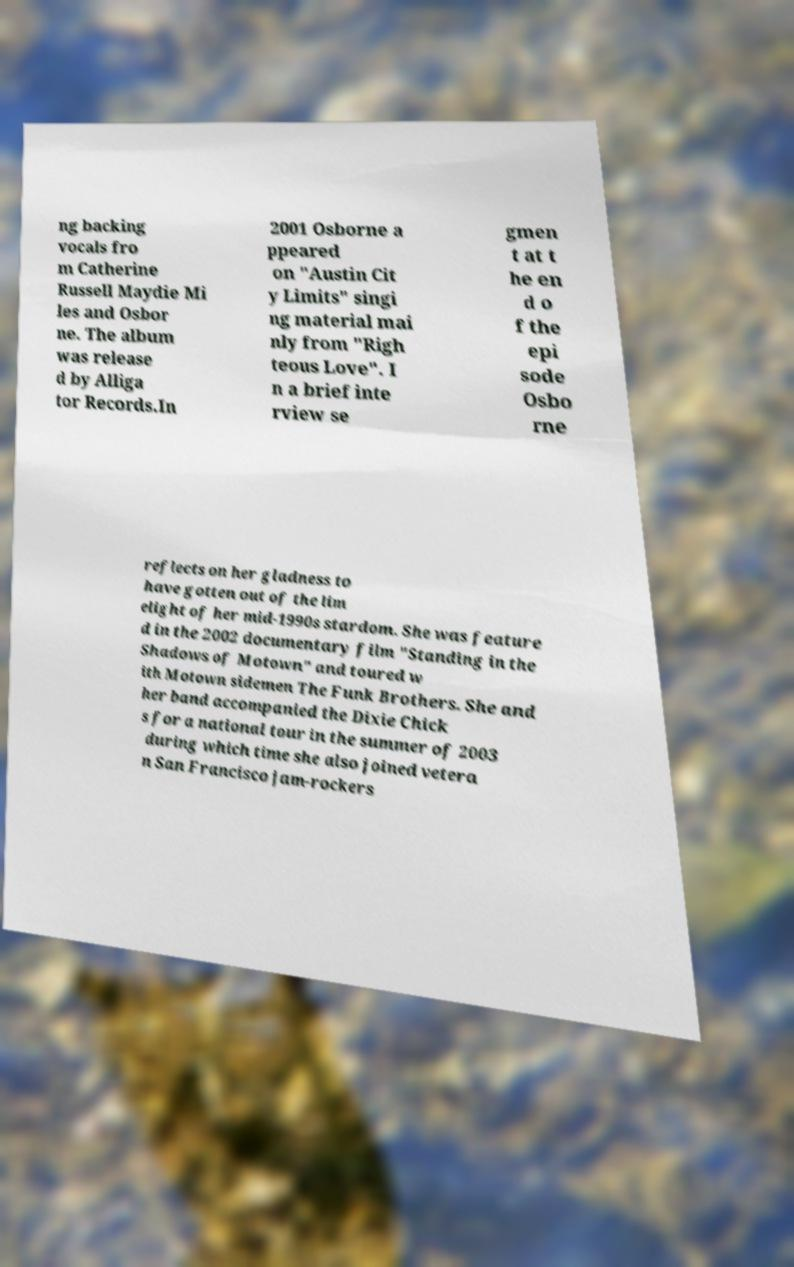Can you read and provide the text displayed in the image?This photo seems to have some interesting text. Can you extract and type it out for me? ng backing vocals fro m Catherine Russell Maydie Mi les and Osbor ne. The album was release d by Alliga tor Records.In 2001 Osborne a ppeared on "Austin Cit y Limits" singi ng material mai nly from "Righ teous Love". I n a brief inte rview se gmen t at t he en d o f the epi sode Osbo rne reflects on her gladness to have gotten out of the lim elight of her mid-1990s stardom. She was feature d in the 2002 documentary film "Standing in the Shadows of Motown" and toured w ith Motown sidemen The Funk Brothers. She and her band accompanied the Dixie Chick s for a national tour in the summer of 2003 during which time she also joined vetera n San Francisco jam-rockers 